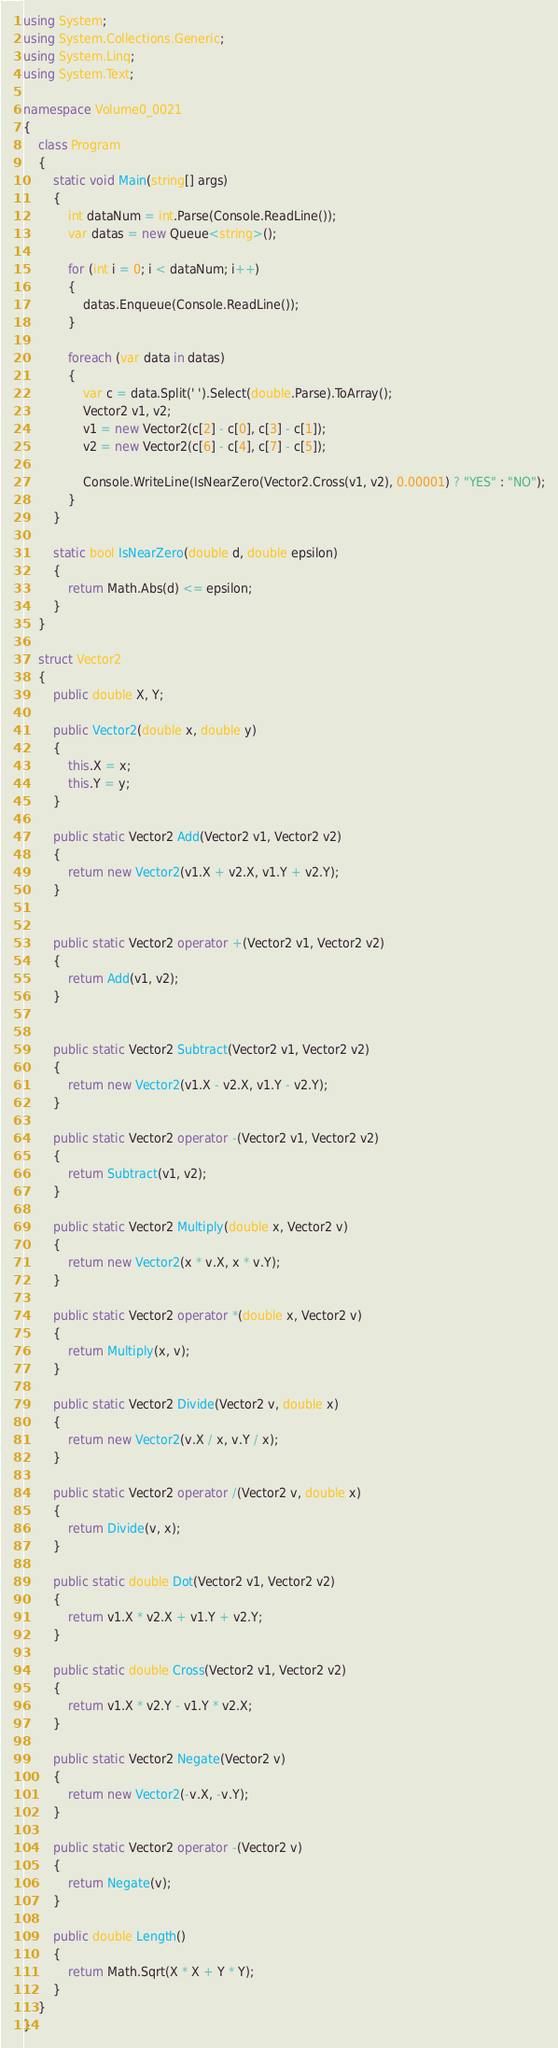Convert code to text. <code><loc_0><loc_0><loc_500><loc_500><_C#_>using System;
using System.Collections.Generic;
using System.Linq;
using System.Text;

namespace Volume0_0021
{
    class Program
    {
        static void Main(string[] args)
        {
            int dataNum = int.Parse(Console.ReadLine());
            var datas = new Queue<string>();

            for (int i = 0; i < dataNum; i++)
            {
                datas.Enqueue(Console.ReadLine());
            }

            foreach (var data in datas)
            {
                var c = data.Split(' ').Select(double.Parse).ToArray();
                Vector2 v1, v2;
                v1 = new Vector2(c[2] - c[0], c[3] - c[1]);
                v2 = new Vector2(c[6] - c[4], c[7] - c[5]);

                Console.WriteLine(IsNearZero(Vector2.Cross(v1, v2), 0.00001) ? "YES" : "NO");
            }
        }

        static bool IsNearZero(double d, double epsilon)
        {
            return Math.Abs(d) <= epsilon;
        }
    }

    struct Vector2
    {
        public double X, Y;

        public Vector2(double x, double y)
        {
            this.X = x;
            this.Y = y;
        }

        public static Vector2 Add(Vector2 v1, Vector2 v2)
        {
            return new Vector2(v1.X + v2.X, v1.Y + v2.Y);
        }


        public static Vector2 operator +(Vector2 v1, Vector2 v2)
        {
            return Add(v1, v2);
        }


        public static Vector2 Subtract(Vector2 v1, Vector2 v2)
        {
            return new Vector2(v1.X - v2.X, v1.Y - v2.Y);
        }

        public static Vector2 operator -(Vector2 v1, Vector2 v2)
        {
            return Subtract(v1, v2);
        }

        public static Vector2 Multiply(double x, Vector2 v)
        {
            return new Vector2(x * v.X, x * v.Y);
        }

        public static Vector2 operator *(double x, Vector2 v)
        {
            return Multiply(x, v);
        }

        public static Vector2 Divide(Vector2 v, double x)
        {
            return new Vector2(v.X / x, v.Y / x);
        }

        public static Vector2 operator /(Vector2 v, double x)
        {
            return Divide(v, x);
        }

        public static double Dot(Vector2 v1, Vector2 v2)
        {
            return v1.X * v2.X + v1.Y + v2.Y;
        }

        public static double Cross(Vector2 v1, Vector2 v2)
        {
            return v1.X * v2.Y - v1.Y * v2.X;
        }

        public static Vector2 Negate(Vector2 v)
        {
            return new Vector2(-v.X, -v.Y);
        }

        public static Vector2 operator -(Vector2 v)
        {
            return Negate(v);
        }

        public double Length()
        {
            return Math.Sqrt(X * X + Y * Y);
        }
    }
}</code> 